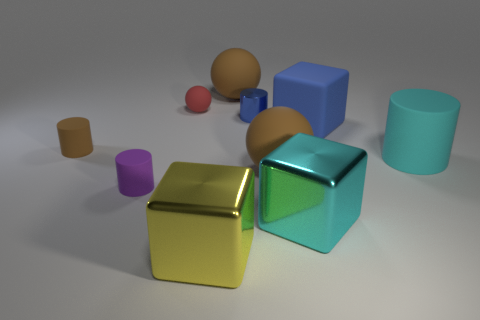Do the objects in the image exhibit any particular pattern or arrangement? At first glance, the objects do not seem to follow a strict pattern. However, upon closer observation, one could interpret the spatial distribution as somewhat uniform, with objects being placed with space in between them. This arrangement could be intentional to highlight the individual characteristics of each shape and color, or simply to create a visually balanced composition. 